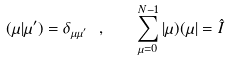<formula> <loc_0><loc_0><loc_500><loc_500>( \mu | \mu ^ { \prime } ) = \delta _ { \mu \mu ^ { \prime } } \ , \quad \sum ^ { N - 1 } _ { \mu = 0 } | \mu ) ( \mu | = \hat { I }</formula> 